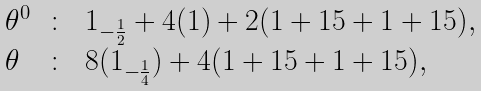<formula> <loc_0><loc_0><loc_500><loc_500>\begin{array} { l c l } \theta ^ { 0 } & \colon & 1 _ { - \frac { 1 } { 2 } } + 4 ( 1 ) + 2 ( 1 + 1 5 + 1 + 1 5 ) , \\ \theta & \colon & 8 ( 1 _ { - \frac { 1 } { 4 } } ) + 4 ( 1 + 1 5 + 1 + 1 5 ) , \end{array}</formula> 